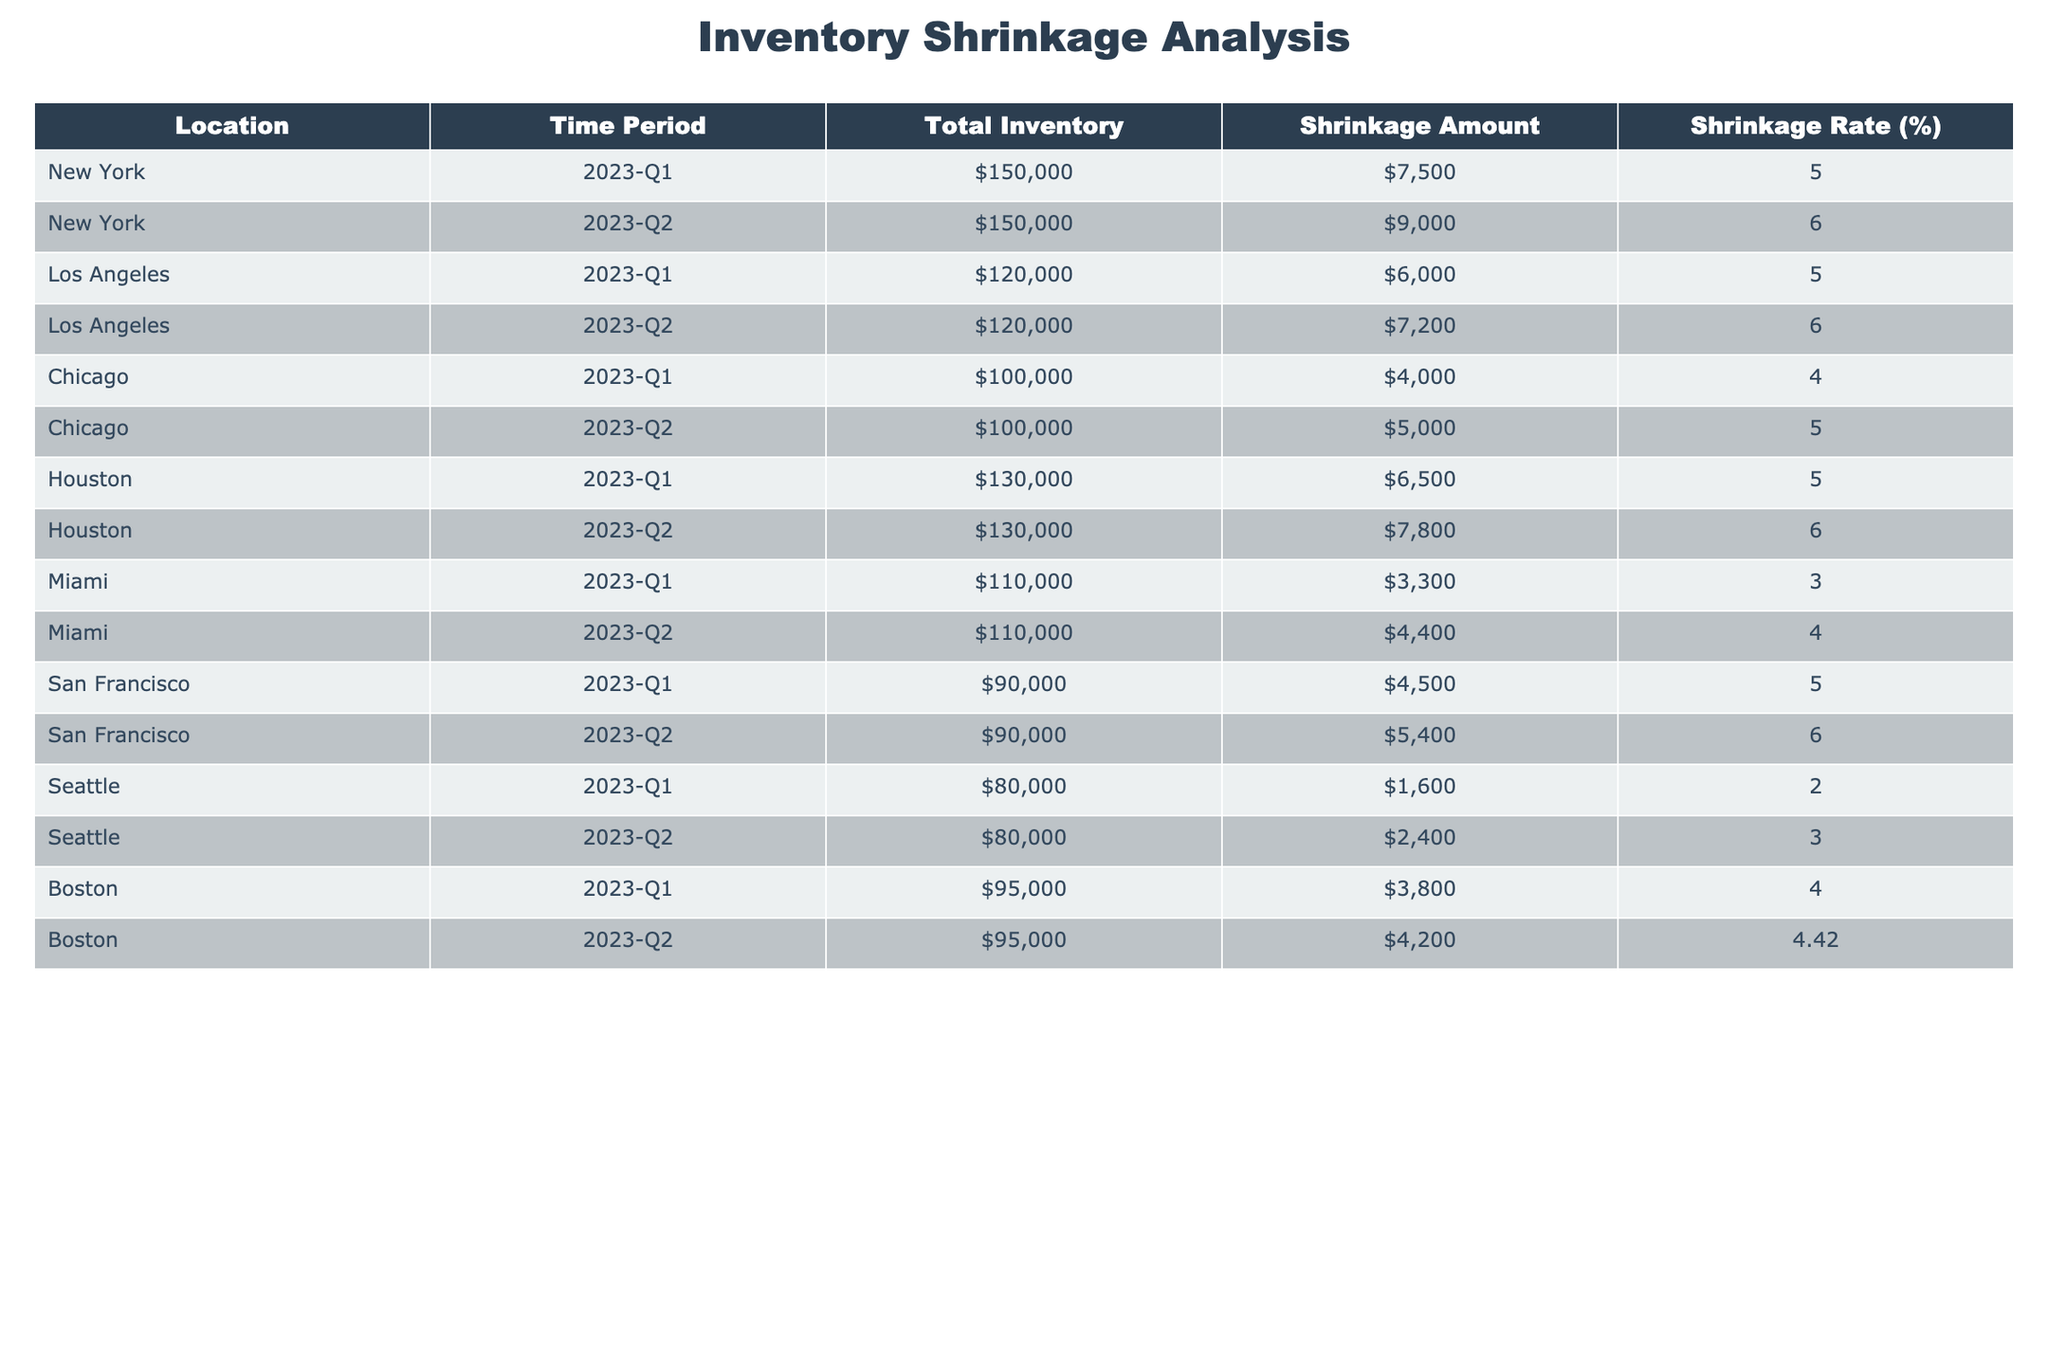What was the shrinkage rate for New York in Q2 2023? The table shows that the shrinkage rate for New York in Q2 2023 is listed as 6.00%.
Answer: 6.00% Which location had the highest total inventory during the first quarter of 2023? Reviewing the table, New York has the highest total inventory at 150,000 in Q1 2023, compared to other locations.
Answer: New York What is the average shrinkage rate for Los Angeles over the two quarters? For Los Angeles, the shrinkage rates are 5.00% (Q1) and 6.00% (Q2), summing these gives 11.00%. The average is 11.00% / 2 = 5.50%.
Answer: 5.50% Did Miami have a shrinkage rate greater than 4% in both quarters? In Q1, Miami's shrinkage rate is 3.00%, which does not exceed 4%. In Q2, it is 4.00%, which is equal but not greater. Thus, the statement is false.
Answer: No Which location showed an increase in shrinkage rate from Q1 to Q2 that was above 1%? Evaluating the data, both New York (5.00% to 6.00%) and Los Angeles (5.00% to 6.00%) show increases of 1%. Houston also shows an increase from 5.00% to 6.00%, while Chicago (4.00% to 5.00%) and San Francisco (5.00% to 6.00%) do as well. All these are above 1%.
Answer: Yes What was the total shrinkage amount for Boston across the two quarters? The shrinkage amounts for Boston in Q1 is 3,800 and in Q2 is 4,200. Adding these two amounts gives 3,800 + 4,200 = 8,000.
Answer: 8,000 Which location had a shrinkage rate of less than 3% in any quarter? By checking the table, Seattle shows a shrinkage rate of 2.00% during Q1 2023, which is less than 3%.
Answer: Yes What is the difference in total inventory between Chicago and Houston? Chicago's total inventory is 100,000 and Houston's is 130,000. The difference is 130,000 - 100,000 = 30,000.
Answer: 30,000 